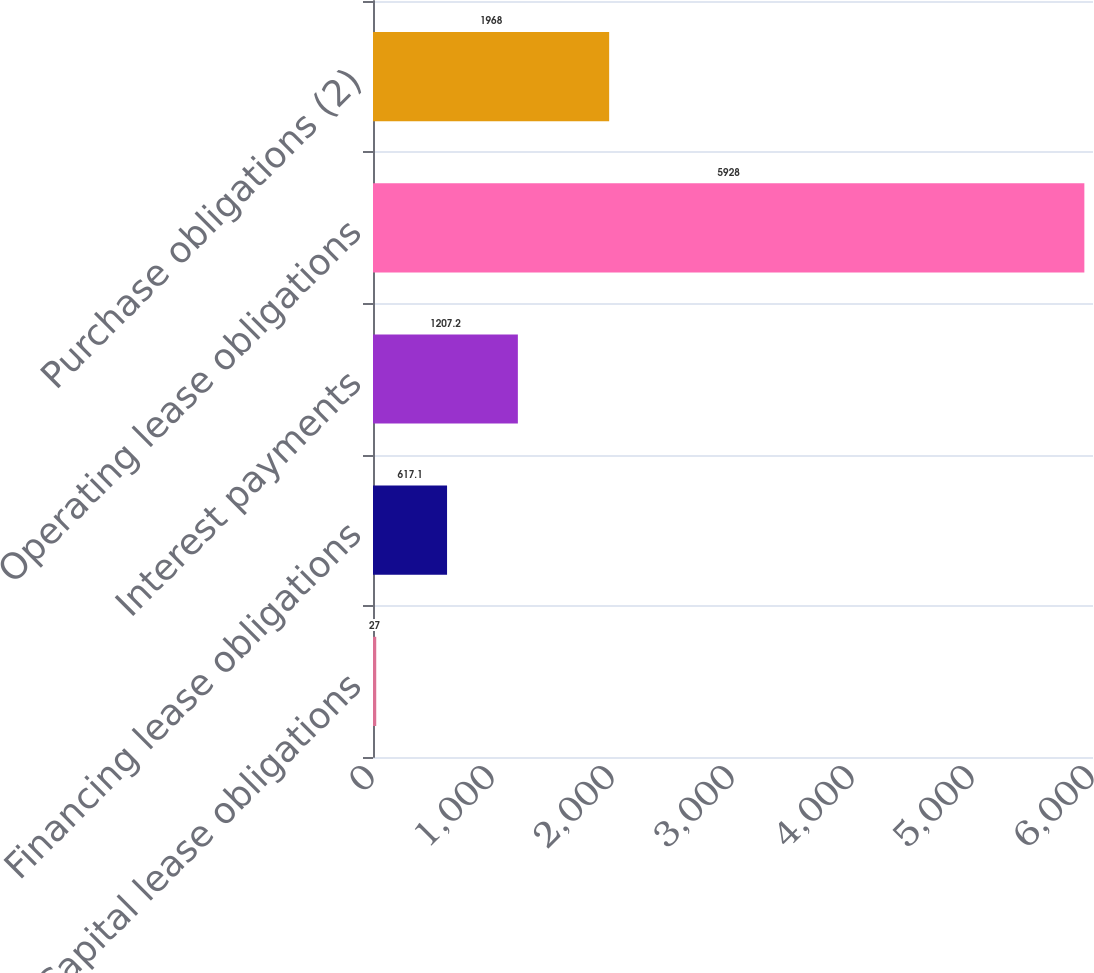<chart> <loc_0><loc_0><loc_500><loc_500><bar_chart><fcel>Capital lease obligations<fcel>Financing lease obligations<fcel>Interest payments<fcel>Operating lease obligations<fcel>Purchase obligations (2)<nl><fcel>27<fcel>617.1<fcel>1207.2<fcel>5928<fcel>1968<nl></chart> 